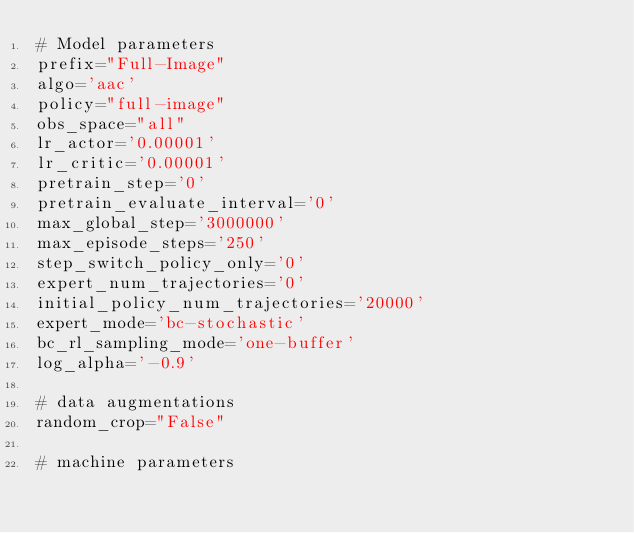Convert code to text. <code><loc_0><loc_0><loc_500><loc_500><_Bash_># Model parameters
prefix="Full-Image"
algo='aac'
policy="full-image"
obs_space="all"
lr_actor='0.00001'
lr_critic='0.00001'
pretrain_step='0'
pretrain_evaluate_interval='0'
max_global_step='3000000'
max_episode_steps='250'
step_switch_policy_only='0'
expert_num_trajectories='0'
initial_policy_num_trajectories='20000'
expert_mode='bc-stochastic'
bc_rl_sampling_mode='one-buffer'
log_alpha='-0.9'

# data augmentations
random_crop="False"

# machine parameters</code> 